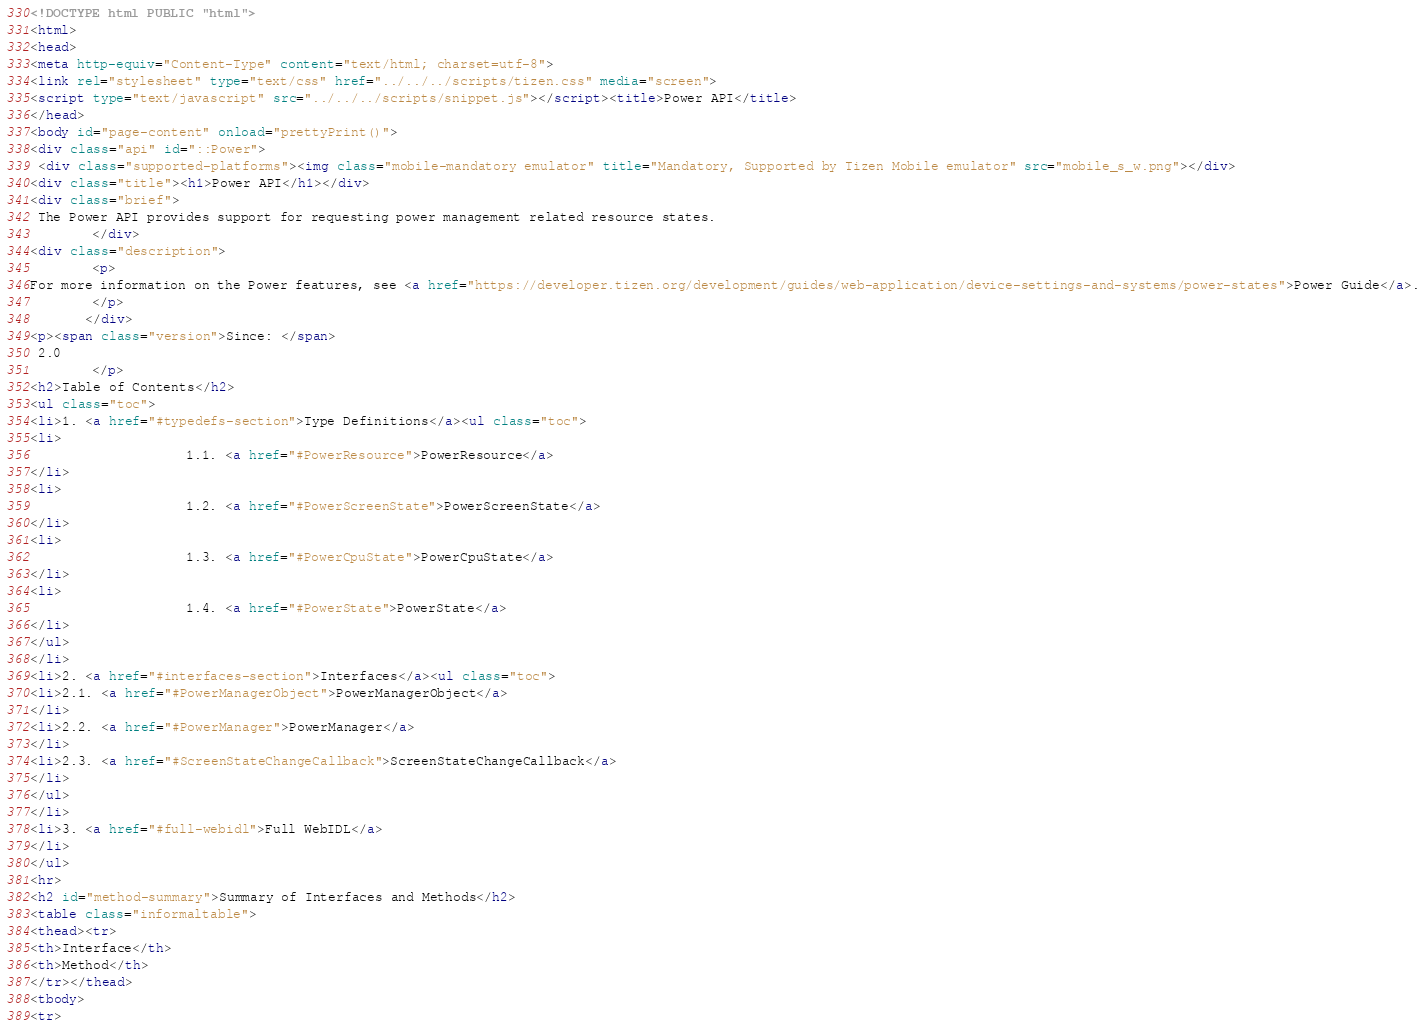Convert code to text. <code><loc_0><loc_0><loc_500><loc_500><_HTML_><!DOCTYPE html PUBLIC "html">
<html>
<head>
<meta http-equiv="Content-Type" content="text/html; charset=utf-8">
<link rel="stylesheet" type="text/css" href="../../../scripts/tizen.css" media="screen">
<script type="text/javascript" src="../../../scripts/snippet.js"></script><title>Power API</title>
</head>
<body id="page-content" onload="prettyPrint()">
<div class="api" id="::Power">
 <div class="supported-platforms"><img class="mobile-mandatory emulator" title="Mandatory, Supported by Tizen Mobile emulator" src="mobile_s_w.png"></div>
<div class="title"><h1>Power API</h1></div>
<div class="brief">
 The Power API provides support for requesting power management related resource states.
        </div>
<div class="description">
        <p>
For more information on the Power features, see <a href="https://developer.tizen.org/development/guides/web-application/device-settings-and-systems/power-states">Power Guide</a>.
        </p>
       </div>
<p><span class="version">Since: </span>
 2.0
        </p>
<h2>Table of Contents</h2>
<ul class="toc">
<li>1. <a href="#typedefs-section">Type Definitions</a><ul class="toc">
<li>
                    1.1. <a href="#PowerResource">PowerResource</a>
</li>
<li>
                    1.2. <a href="#PowerScreenState">PowerScreenState</a>
</li>
<li>
                    1.3. <a href="#PowerCpuState">PowerCpuState</a>
</li>
<li>
                    1.4. <a href="#PowerState">PowerState</a>
</li>
</ul>
</li>
<li>2. <a href="#interfaces-section">Interfaces</a><ul class="toc">
<li>2.1. <a href="#PowerManagerObject">PowerManagerObject</a>
</li>
<li>2.2. <a href="#PowerManager">PowerManager</a>
</li>
<li>2.3. <a href="#ScreenStateChangeCallback">ScreenStateChangeCallback</a>
</li>
</ul>
</li>
<li>3. <a href="#full-webidl">Full WebIDL</a>
</li>
</ul>
<hr>
<h2 id="method-summary">Summary of Interfaces and Methods</h2>
<table class="informaltable">
<thead><tr>
<th>Interface</th>
<th>Method</th>
</tr></thead>
<tbody>
<tr></code> 